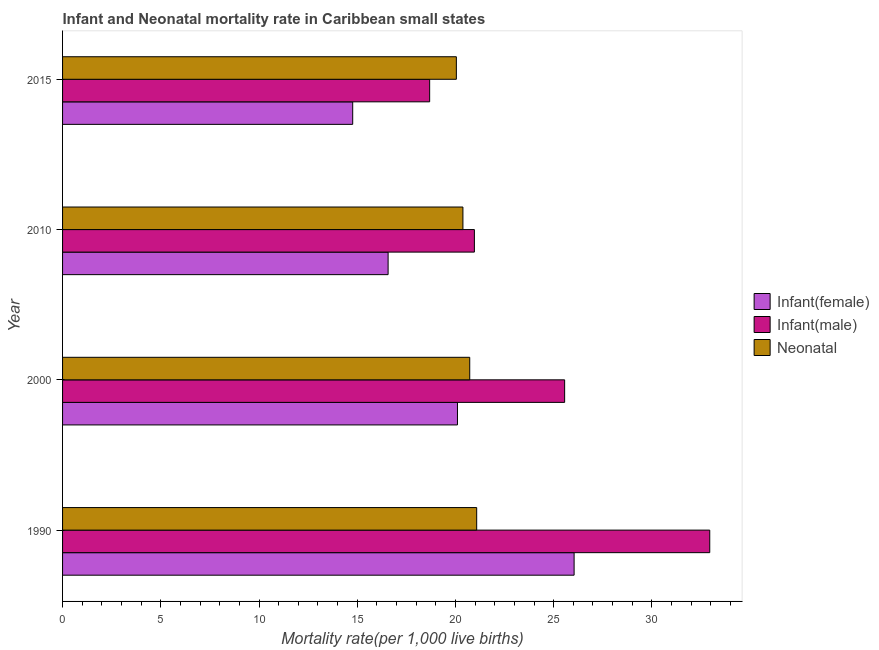How many bars are there on the 3rd tick from the top?
Your answer should be very brief. 3. What is the label of the 2nd group of bars from the top?
Your answer should be very brief. 2010. In how many cases, is the number of bars for a given year not equal to the number of legend labels?
Keep it short and to the point. 0. What is the infant mortality rate(female) in 1990?
Keep it short and to the point. 26.04. Across all years, what is the maximum infant mortality rate(male)?
Your response must be concise. 32.95. Across all years, what is the minimum neonatal mortality rate?
Provide a short and direct response. 20.05. In which year was the neonatal mortality rate maximum?
Your response must be concise. 1990. In which year was the infant mortality rate(male) minimum?
Give a very brief answer. 2015. What is the total infant mortality rate(male) in the graph?
Offer a terse response. 98.15. What is the difference between the neonatal mortality rate in 1990 and that in 2000?
Make the answer very short. 0.35. What is the difference between the neonatal mortality rate in 2010 and the infant mortality rate(male) in 2015?
Ensure brevity in your answer.  1.69. What is the average infant mortality rate(female) per year?
Your response must be concise. 19.37. In the year 1990, what is the difference between the neonatal mortality rate and infant mortality rate(male)?
Make the answer very short. -11.86. In how many years, is the infant mortality rate(male) greater than 31 ?
Provide a succinct answer. 1. What is the ratio of the infant mortality rate(male) in 2000 to that in 2015?
Provide a succinct answer. 1.37. Is the infant mortality rate(male) in 2000 less than that in 2015?
Offer a very short reply. No. What is the difference between the highest and the second highest infant mortality rate(male)?
Keep it short and to the point. 7.39. What is the difference between the highest and the lowest neonatal mortality rate?
Keep it short and to the point. 1.04. What does the 3rd bar from the top in 2000 represents?
Offer a terse response. Infant(female). What does the 3rd bar from the bottom in 2010 represents?
Offer a terse response. Neonatal . Is it the case that in every year, the sum of the infant mortality rate(female) and infant mortality rate(male) is greater than the neonatal mortality rate?
Your response must be concise. Yes. How many bars are there?
Your answer should be very brief. 12. Are all the bars in the graph horizontal?
Offer a terse response. Yes. Are the values on the major ticks of X-axis written in scientific E-notation?
Make the answer very short. No. What is the title of the graph?
Your response must be concise. Infant and Neonatal mortality rate in Caribbean small states. Does "Neonatal" appear as one of the legend labels in the graph?
Provide a short and direct response. No. What is the label or title of the X-axis?
Your answer should be compact. Mortality rate(per 1,0 live births). What is the Mortality rate(per 1,000 live births) of Infant(female) in 1990?
Provide a succinct answer. 26.04. What is the Mortality rate(per 1,000 live births) of Infant(male) in 1990?
Your answer should be compact. 32.95. What is the Mortality rate(per 1,000 live births) of Neonatal  in 1990?
Ensure brevity in your answer.  21.08. What is the Mortality rate(per 1,000 live births) in Infant(female) in 2000?
Make the answer very short. 20.1. What is the Mortality rate(per 1,000 live births) of Infant(male) in 2000?
Keep it short and to the point. 25.56. What is the Mortality rate(per 1,000 live births) in Neonatal  in 2000?
Provide a short and direct response. 20.73. What is the Mortality rate(per 1,000 live births) in Infant(female) in 2010?
Make the answer very short. 16.57. What is the Mortality rate(per 1,000 live births) in Infant(male) in 2010?
Your answer should be compact. 20.96. What is the Mortality rate(per 1,000 live births) in Neonatal  in 2010?
Your response must be concise. 20.38. What is the Mortality rate(per 1,000 live births) in Infant(female) in 2015?
Your response must be concise. 14.77. What is the Mortality rate(per 1,000 live births) of Infant(male) in 2015?
Make the answer very short. 18.69. What is the Mortality rate(per 1,000 live births) in Neonatal  in 2015?
Make the answer very short. 20.05. Across all years, what is the maximum Mortality rate(per 1,000 live births) of Infant(female)?
Give a very brief answer. 26.04. Across all years, what is the maximum Mortality rate(per 1,000 live births) in Infant(male)?
Your answer should be very brief. 32.95. Across all years, what is the maximum Mortality rate(per 1,000 live births) in Neonatal ?
Your answer should be compact. 21.08. Across all years, what is the minimum Mortality rate(per 1,000 live births) in Infant(female)?
Keep it short and to the point. 14.77. Across all years, what is the minimum Mortality rate(per 1,000 live births) in Infant(male)?
Provide a succinct answer. 18.69. Across all years, what is the minimum Mortality rate(per 1,000 live births) in Neonatal ?
Provide a succinct answer. 20.05. What is the total Mortality rate(per 1,000 live births) in Infant(female) in the graph?
Keep it short and to the point. 77.48. What is the total Mortality rate(per 1,000 live births) in Infant(male) in the graph?
Your response must be concise. 98.15. What is the total Mortality rate(per 1,000 live births) of Neonatal  in the graph?
Offer a very short reply. 82.23. What is the difference between the Mortality rate(per 1,000 live births) in Infant(female) in 1990 and that in 2000?
Provide a succinct answer. 5.94. What is the difference between the Mortality rate(per 1,000 live births) in Infant(male) in 1990 and that in 2000?
Ensure brevity in your answer.  7.39. What is the difference between the Mortality rate(per 1,000 live births) in Neonatal  in 1990 and that in 2000?
Offer a terse response. 0.35. What is the difference between the Mortality rate(per 1,000 live births) in Infant(female) in 1990 and that in 2010?
Ensure brevity in your answer.  9.47. What is the difference between the Mortality rate(per 1,000 live births) of Infant(male) in 1990 and that in 2010?
Your response must be concise. 11.98. What is the difference between the Mortality rate(per 1,000 live births) in Neonatal  in 1990 and that in 2010?
Ensure brevity in your answer.  0.7. What is the difference between the Mortality rate(per 1,000 live births) of Infant(female) in 1990 and that in 2015?
Keep it short and to the point. 11.27. What is the difference between the Mortality rate(per 1,000 live births) in Infant(male) in 1990 and that in 2015?
Ensure brevity in your answer.  14.26. What is the difference between the Mortality rate(per 1,000 live births) of Neonatal  in 1990 and that in 2015?
Your answer should be compact. 1.04. What is the difference between the Mortality rate(per 1,000 live births) of Infant(female) in 2000 and that in 2010?
Make the answer very short. 3.53. What is the difference between the Mortality rate(per 1,000 live births) of Infant(male) in 2000 and that in 2010?
Your answer should be compact. 4.59. What is the difference between the Mortality rate(per 1,000 live births) in Neonatal  in 2000 and that in 2010?
Your response must be concise. 0.35. What is the difference between the Mortality rate(per 1,000 live births) of Infant(female) in 2000 and that in 2015?
Keep it short and to the point. 5.33. What is the difference between the Mortality rate(per 1,000 live births) of Infant(male) in 2000 and that in 2015?
Make the answer very short. 6.87. What is the difference between the Mortality rate(per 1,000 live births) in Neonatal  in 2000 and that in 2015?
Provide a succinct answer. 0.68. What is the difference between the Mortality rate(per 1,000 live births) in Infant(female) in 2010 and that in 2015?
Provide a short and direct response. 1.8. What is the difference between the Mortality rate(per 1,000 live births) in Infant(male) in 2010 and that in 2015?
Make the answer very short. 2.28. What is the difference between the Mortality rate(per 1,000 live births) in Neonatal  in 2010 and that in 2015?
Your answer should be compact. 0.33. What is the difference between the Mortality rate(per 1,000 live births) of Infant(female) in 1990 and the Mortality rate(per 1,000 live births) of Infant(male) in 2000?
Make the answer very short. 0.48. What is the difference between the Mortality rate(per 1,000 live births) of Infant(female) in 1990 and the Mortality rate(per 1,000 live births) of Neonatal  in 2000?
Give a very brief answer. 5.31. What is the difference between the Mortality rate(per 1,000 live births) in Infant(male) in 1990 and the Mortality rate(per 1,000 live births) in Neonatal  in 2000?
Keep it short and to the point. 12.22. What is the difference between the Mortality rate(per 1,000 live births) of Infant(female) in 1990 and the Mortality rate(per 1,000 live births) of Infant(male) in 2010?
Ensure brevity in your answer.  5.08. What is the difference between the Mortality rate(per 1,000 live births) of Infant(female) in 1990 and the Mortality rate(per 1,000 live births) of Neonatal  in 2010?
Make the answer very short. 5.66. What is the difference between the Mortality rate(per 1,000 live births) of Infant(male) in 1990 and the Mortality rate(per 1,000 live births) of Neonatal  in 2010?
Provide a succinct answer. 12.56. What is the difference between the Mortality rate(per 1,000 live births) of Infant(female) in 1990 and the Mortality rate(per 1,000 live births) of Infant(male) in 2015?
Keep it short and to the point. 7.35. What is the difference between the Mortality rate(per 1,000 live births) in Infant(female) in 1990 and the Mortality rate(per 1,000 live births) in Neonatal  in 2015?
Ensure brevity in your answer.  5.99. What is the difference between the Mortality rate(per 1,000 live births) of Infant(male) in 1990 and the Mortality rate(per 1,000 live births) of Neonatal  in 2015?
Your response must be concise. 12.9. What is the difference between the Mortality rate(per 1,000 live births) in Infant(female) in 2000 and the Mortality rate(per 1,000 live births) in Infant(male) in 2010?
Provide a succinct answer. -0.86. What is the difference between the Mortality rate(per 1,000 live births) of Infant(female) in 2000 and the Mortality rate(per 1,000 live births) of Neonatal  in 2010?
Your answer should be very brief. -0.28. What is the difference between the Mortality rate(per 1,000 live births) in Infant(male) in 2000 and the Mortality rate(per 1,000 live births) in Neonatal  in 2010?
Your answer should be compact. 5.18. What is the difference between the Mortality rate(per 1,000 live births) of Infant(female) in 2000 and the Mortality rate(per 1,000 live births) of Infant(male) in 2015?
Keep it short and to the point. 1.42. What is the difference between the Mortality rate(per 1,000 live births) in Infant(female) in 2000 and the Mortality rate(per 1,000 live births) in Neonatal  in 2015?
Your response must be concise. 0.06. What is the difference between the Mortality rate(per 1,000 live births) in Infant(male) in 2000 and the Mortality rate(per 1,000 live births) in Neonatal  in 2015?
Offer a terse response. 5.51. What is the difference between the Mortality rate(per 1,000 live births) of Infant(female) in 2010 and the Mortality rate(per 1,000 live births) of Infant(male) in 2015?
Make the answer very short. -2.11. What is the difference between the Mortality rate(per 1,000 live births) of Infant(female) in 2010 and the Mortality rate(per 1,000 live births) of Neonatal  in 2015?
Keep it short and to the point. -3.47. What is the difference between the Mortality rate(per 1,000 live births) in Infant(male) in 2010 and the Mortality rate(per 1,000 live births) in Neonatal  in 2015?
Your answer should be very brief. 0.92. What is the average Mortality rate(per 1,000 live births) of Infant(female) per year?
Provide a short and direct response. 19.37. What is the average Mortality rate(per 1,000 live births) in Infant(male) per year?
Provide a succinct answer. 24.54. What is the average Mortality rate(per 1,000 live births) in Neonatal  per year?
Your answer should be very brief. 20.56. In the year 1990, what is the difference between the Mortality rate(per 1,000 live births) in Infant(female) and Mortality rate(per 1,000 live births) in Infant(male)?
Make the answer very short. -6.91. In the year 1990, what is the difference between the Mortality rate(per 1,000 live births) in Infant(female) and Mortality rate(per 1,000 live births) in Neonatal ?
Keep it short and to the point. 4.96. In the year 1990, what is the difference between the Mortality rate(per 1,000 live births) of Infant(male) and Mortality rate(per 1,000 live births) of Neonatal ?
Make the answer very short. 11.86. In the year 2000, what is the difference between the Mortality rate(per 1,000 live births) in Infant(female) and Mortality rate(per 1,000 live births) in Infant(male)?
Offer a terse response. -5.46. In the year 2000, what is the difference between the Mortality rate(per 1,000 live births) of Infant(female) and Mortality rate(per 1,000 live births) of Neonatal ?
Provide a short and direct response. -0.62. In the year 2000, what is the difference between the Mortality rate(per 1,000 live births) of Infant(male) and Mortality rate(per 1,000 live births) of Neonatal ?
Provide a short and direct response. 4.83. In the year 2010, what is the difference between the Mortality rate(per 1,000 live births) in Infant(female) and Mortality rate(per 1,000 live births) in Infant(male)?
Offer a very short reply. -4.39. In the year 2010, what is the difference between the Mortality rate(per 1,000 live births) of Infant(female) and Mortality rate(per 1,000 live births) of Neonatal ?
Offer a terse response. -3.81. In the year 2010, what is the difference between the Mortality rate(per 1,000 live births) of Infant(male) and Mortality rate(per 1,000 live births) of Neonatal ?
Ensure brevity in your answer.  0.58. In the year 2015, what is the difference between the Mortality rate(per 1,000 live births) in Infant(female) and Mortality rate(per 1,000 live births) in Infant(male)?
Give a very brief answer. -3.92. In the year 2015, what is the difference between the Mortality rate(per 1,000 live births) of Infant(female) and Mortality rate(per 1,000 live births) of Neonatal ?
Provide a short and direct response. -5.28. In the year 2015, what is the difference between the Mortality rate(per 1,000 live births) of Infant(male) and Mortality rate(per 1,000 live births) of Neonatal ?
Ensure brevity in your answer.  -1.36. What is the ratio of the Mortality rate(per 1,000 live births) of Infant(female) in 1990 to that in 2000?
Provide a short and direct response. 1.3. What is the ratio of the Mortality rate(per 1,000 live births) in Infant(male) in 1990 to that in 2000?
Your answer should be very brief. 1.29. What is the ratio of the Mortality rate(per 1,000 live births) of Neonatal  in 1990 to that in 2000?
Make the answer very short. 1.02. What is the ratio of the Mortality rate(per 1,000 live births) of Infant(female) in 1990 to that in 2010?
Offer a terse response. 1.57. What is the ratio of the Mortality rate(per 1,000 live births) of Infant(male) in 1990 to that in 2010?
Offer a terse response. 1.57. What is the ratio of the Mortality rate(per 1,000 live births) of Neonatal  in 1990 to that in 2010?
Your response must be concise. 1.03. What is the ratio of the Mortality rate(per 1,000 live births) of Infant(female) in 1990 to that in 2015?
Give a very brief answer. 1.76. What is the ratio of the Mortality rate(per 1,000 live births) of Infant(male) in 1990 to that in 2015?
Make the answer very short. 1.76. What is the ratio of the Mortality rate(per 1,000 live births) in Neonatal  in 1990 to that in 2015?
Provide a short and direct response. 1.05. What is the ratio of the Mortality rate(per 1,000 live births) of Infant(female) in 2000 to that in 2010?
Provide a short and direct response. 1.21. What is the ratio of the Mortality rate(per 1,000 live births) of Infant(male) in 2000 to that in 2010?
Ensure brevity in your answer.  1.22. What is the ratio of the Mortality rate(per 1,000 live births) in Neonatal  in 2000 to that in 2010?
Keep it short and to the point. 1.02. What is the ratio of the Mortality rate(per 1,000 live births) of Infant(female) in 2000 to that in 2015?
Provide a short and direct response. 1.36. What is the ratio of the Mortality rate(per 1,000 live births) of Infant(male) in 2000 to that in 2015?
Provide a short and direct response. 1.37. What is the ratio of the Mortality rate(per 1,000 live births) of Neonatal  in 2000 to that in 2015?
Your response must be concise. 1.03. What is the ratio of the Mortality rate(per 1,000 live births) in Infant(female) in 2010 to that in 2015?
Your response must be concise. 1.12. What is the ratio of the Mortality rate(per 1,000 live births) of Infant(male) in 2010 to that in 2015?
Your response must be concise. 1.12. What is the ratio of the Mortality rate(per 1,000 live births) in Neonatal  in 2010 to that in 2015?
Your answer should be very brief. 1.02. What is the difference between the highest and the second highest Mortality rate(per 1,000 live births) of Infant(female)?
Make the answer very short. 5.94. What is the difference between the highest and the second highest Mortality rate(per 1,000 live births) in Infant(male)?
Keep it short and to the point. 7.39. What is the difference between the highest and the second highest Mortality rate(per 1,000 live births) of Neonatal ?
Give a very brief answer. 0.35. What is the difference between the highest and the lowest Mortality rate(per 1,000 live births) of Infant(female)?
Ensure brevity in your answer.  11.27. What is the difference between the highest and the lowest Mortality rate(per 1,000 live births) of Infant(male)?
Your answer should be very brief. 14.26. What is the difference between the highest and the lowest Mortality rate(per 1,000 live births) in Neonatal ?
Your answer should be compact. 1.04. 